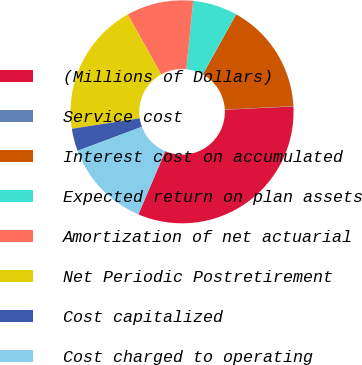Convert chart to OTSL. <chart><loc_0><loc_0><loc_500><loc_500><pie_chart><fcel>(Millions of Dollars)<fcel>Service cost<fcel>Interest cost on accumulated<fcel>Expected return on plan assets<fcel>Amortization of net actuarial<fcel>Net Periodic Postretirement<fcel>Cost capitalized<fcel>Cost charged to operating<nl><fcel>32.18%<fcel>0.05%<fcel>16.12%<fcel>6.47%<fcel>9.69%<fcel>19.33%<fcel>3.26%<fcel>12.9%<nl></chart> 